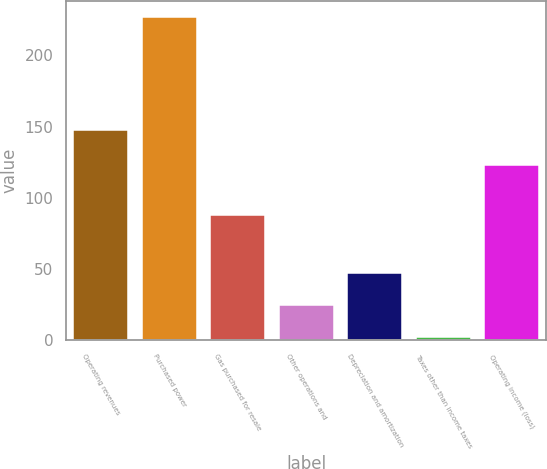<chart> <loc_0><loc_0><loc_500><loc_500><bar_chart><fcel>Operating revenues<fcel>Purchased power<fcel>Gas purchased for resale<fcel>Other operations and<fcel>Depreciation and amortization<fcel>Taxes other than income taxes<fcel>Operating income (loss)<nl><fcel>148<fcel>227<fcel>88<fcel>24.5<fcel>47<fcel>2<fcel>123<nl></chart> 